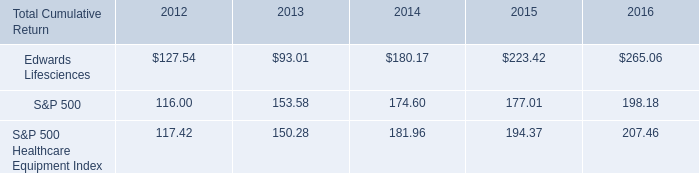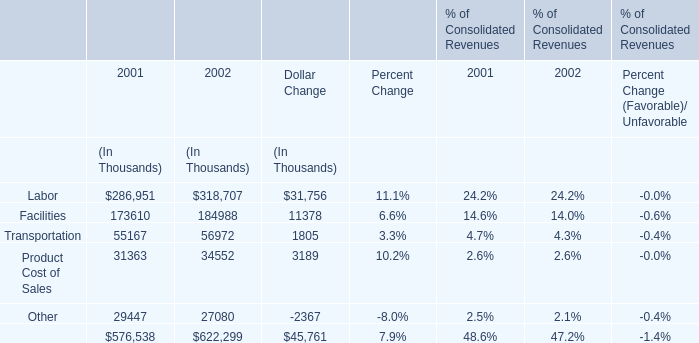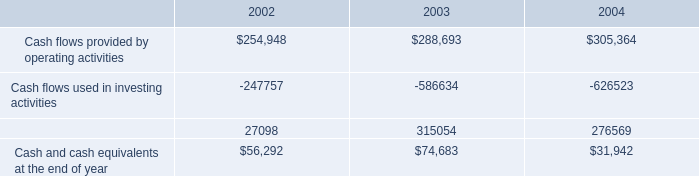What is the total value of Labor, Facilities, Transportation and Product Cost of Sales in in 2001? (in thousand) 
Computations: (((286951 + 173610) + 55167) + 31363)
Answer: 547091.0. 